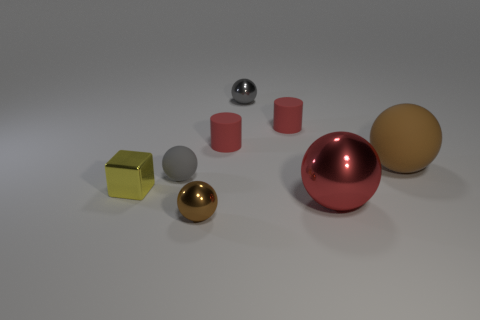Subtract all big red shiny balls. How many balls are left? 4 Subtract all yellow cylinders. How many brown spheres are left? 2 Add 2 gray spheres. How many objects exist? 10 Subtract all brown spheres. How many spheres are left? 3 Subtract 2 balls. How many balls are left? 3 Subtract all cubes. How many objects are left? 7 Subtract all green cubes. Subtract all red cylinders. How many cubes are left? 1 Subtract all cylinders. Subtract all small gray metallic objects. How many objects are left? 5 Add 4 matte objects. How many matte objects are left? 8 Add 5 brown matte spheres. How many brown matte spheres exist? 6 